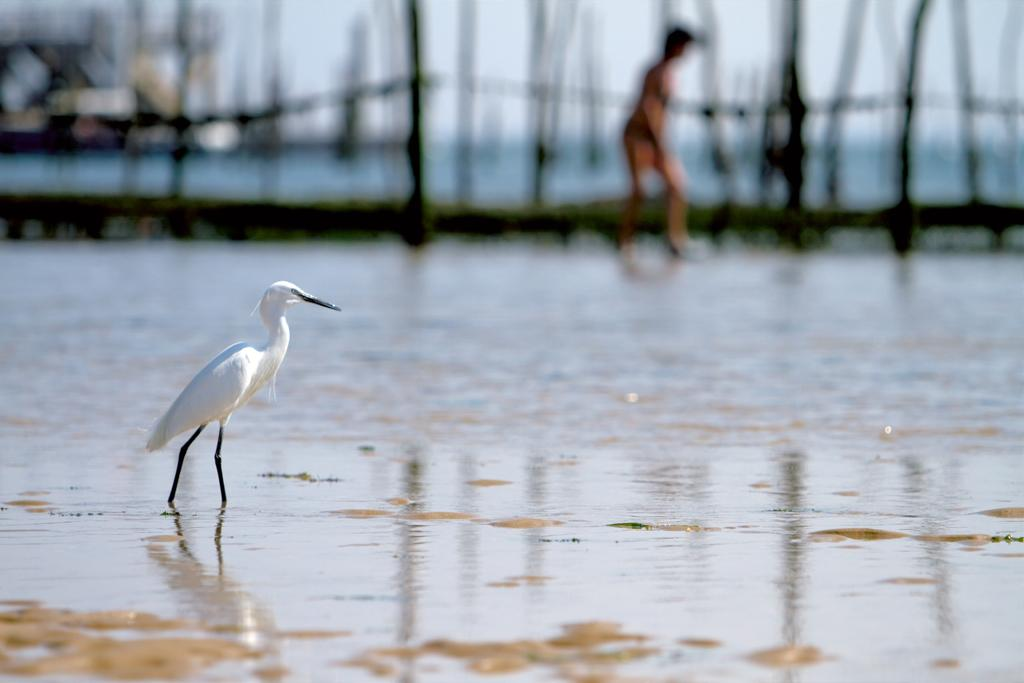What type of bird is in the image? There is a white crane in the image. Where is the crane located in the image? The crane is standing in the water. What is visible in the image besides the crane? There is water visible in the image. Can you describe the background of the image? There is a person walking in the background of the image. What type of boundary can be seen in the image? There is no boundary present in the image; it features a white crane standing in the water with a person walking in the background. What substance is the crane made of in the image? The crane is a living bird, not a substance, so it cannot be described in those terms. 